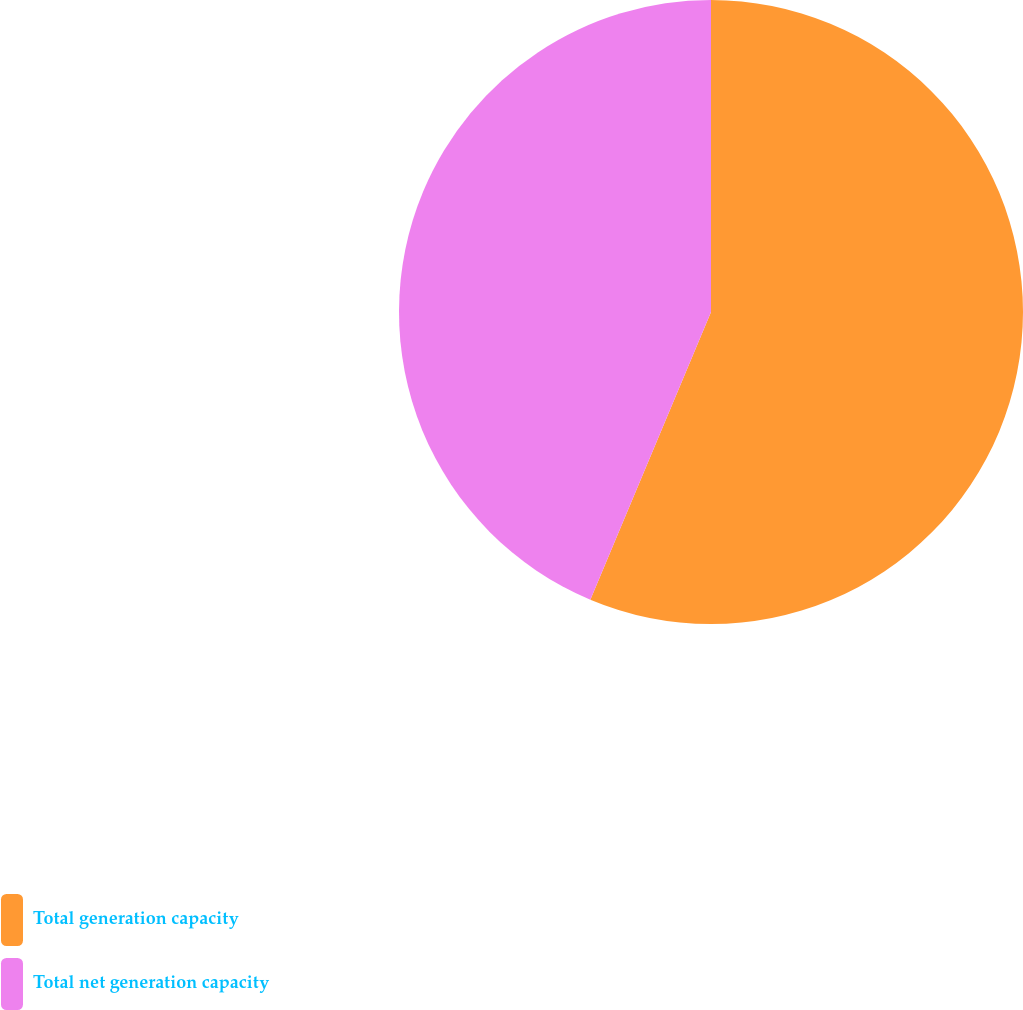Convert chart. <chart><loc_0><loc_0><loc_500><loc_500><pie_chart><fcel>Total generation capacity<fcel>Total net generation capacity<nl><fcel>56.32%<fcel>43.68%<nl></chart> 